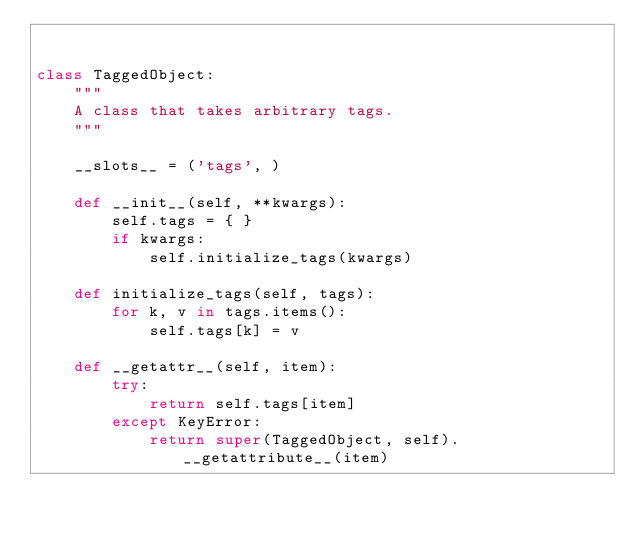<code> <loc_0><loc_0><loc_500><loc_500><_Python_>

class TaggedObject:
    """
    A class that takes arbitrary tags.
    """

    __slots__ = ('tags', )

    def __init__(self, **kwargs):
        self.tags = { }
        if kwargs:
            self.initialize_tags(kwargs)

    def initialize_tags(self, tags):
        for k, v in tags.items():
            self.tags[k] = v

    def __getattr__(self, item):
        try:
            return self.tags[item]
        except KeyError:
            return super(TaggedObject, self).__getattribute__(item)
</code> 